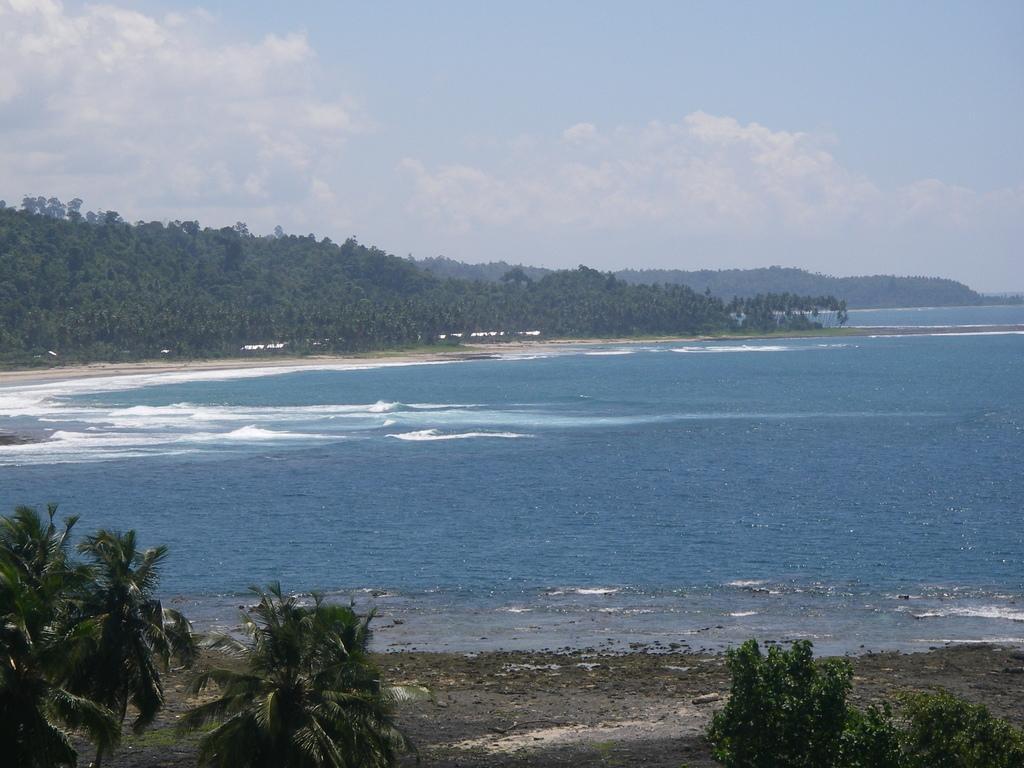Describe this image in one or two sentences. In this image I can see few trees, the ground and the water. In the background I can see few mountains, few trees , the ground, the water and the sky. 